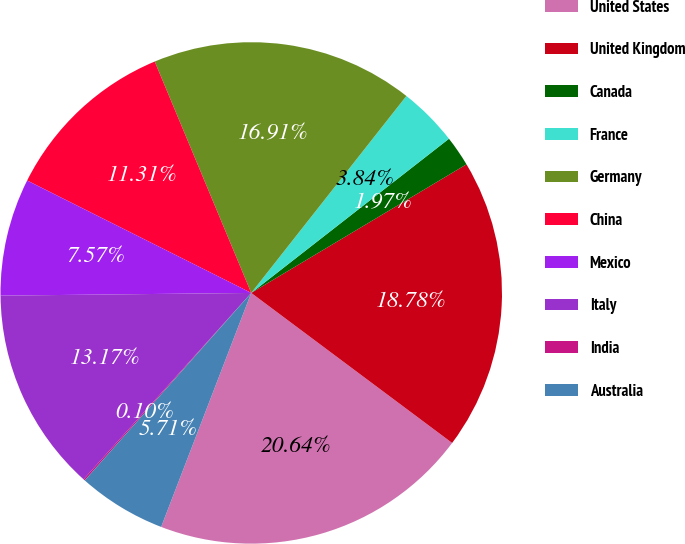Convert chart to OTSL. <chart><loc_0><loc_0><loc_500><loc_500><pie_chart><fcel>United States<fcel>United Kingdom<fcel>Canada<fcel>France<fcel>Germany<fcel>China<fcel>Mexico<fcel>Italy<fcel>India<fcel>Australia<nl><fcel>20.64%<fcel>18.78%<fcel>1.97%<fcel>3.84%<fcel>16.91%<fcel>11.31%<fcel>7.57%<fcel>13.17%<fcel>0.1%<fcel>5.71%<nl></chart> 